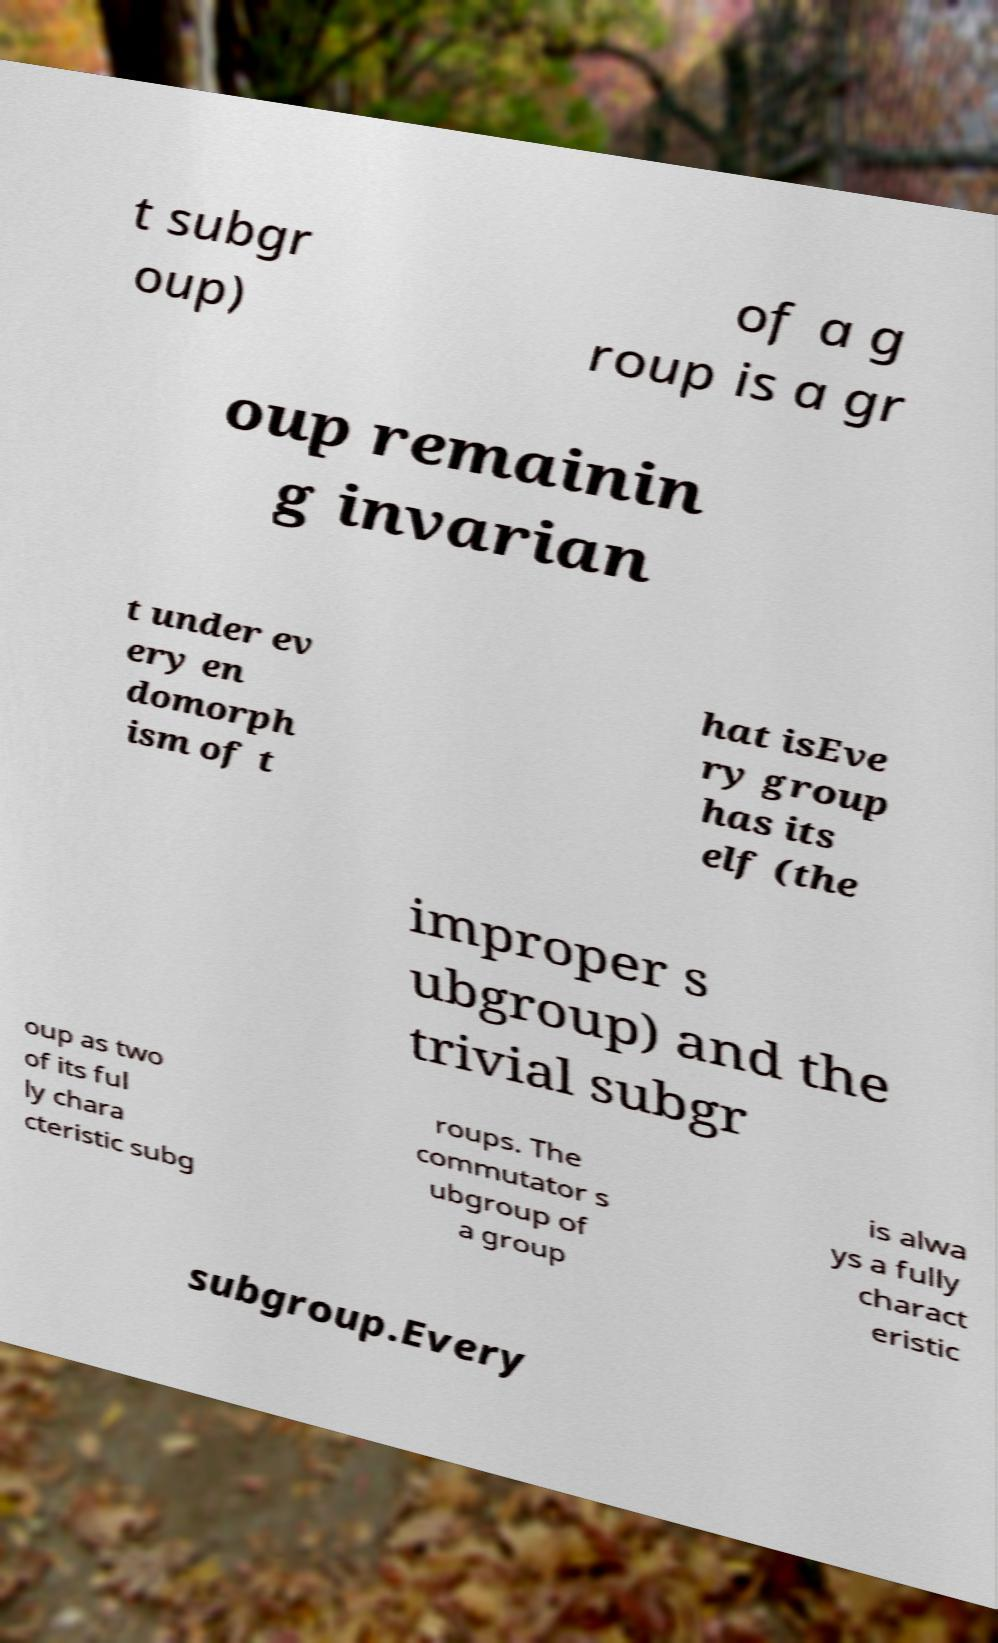Please read and relay the text visible in this image. What does it say? t subgr oup) of a g roup is a gr oup remainin g invarian t under ev ery en domorph ism of t hat isEve ry group has its elf (the improper s ubgroup) and the trivial subgr oup as two of its ful ly chara cteristic subg roups. The commutator s ubgroup of a group is alwa ys a fully charact eristic subgroup.Every 